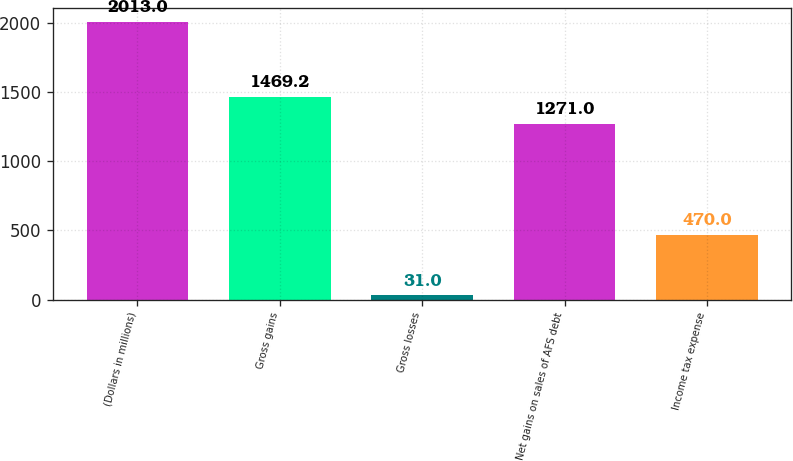<chart> <loc_0><loc_0><loc_500><loc_500><bar_chart><fcel>(Dollars in millions)<fcel>Gross gains<fcel>Gross losses<fcel>Net gains on sales of AFS debt<fcel>Income tax expense<nl><fcel>2013<fcel>1469.2<fcel>31<fcel>1271<fcel>470<nl></chart> 